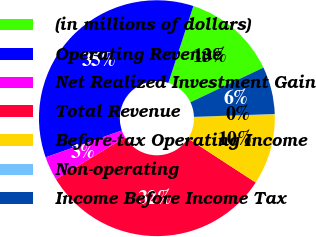Convert chart. <chart><loc_0><loc_0><loc_500><loc_500><pie_chart><fcel>(in millions of dollars)<fcel>Operating Revenue<fcel>Net Realized Investment Gain<fcel>Total Revenue<fcel>Before-tax Operating Income<fcel>Non-operating<fcel>Income Before Income Tax<nl><fcel>12.94%<fcel>35.39%<fcel>3.26%<fcel>32.17%<fcel>9.71%<fcel>0.04%<fcel>6.49%<nl></chart> 